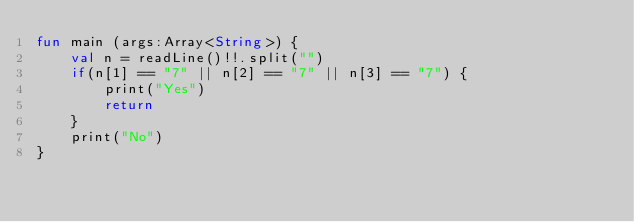<code> <loc_0><loc_0><loc_500><loc_500><_Kotlin_>fun main (args:Array<String>) {
    val n = readLine()!!.split("")
    if(n[1] == "7" || n[2] == "7" || n[3] == "7") {
        print("Yes")
        return
    }
    print("No")
}</code> 